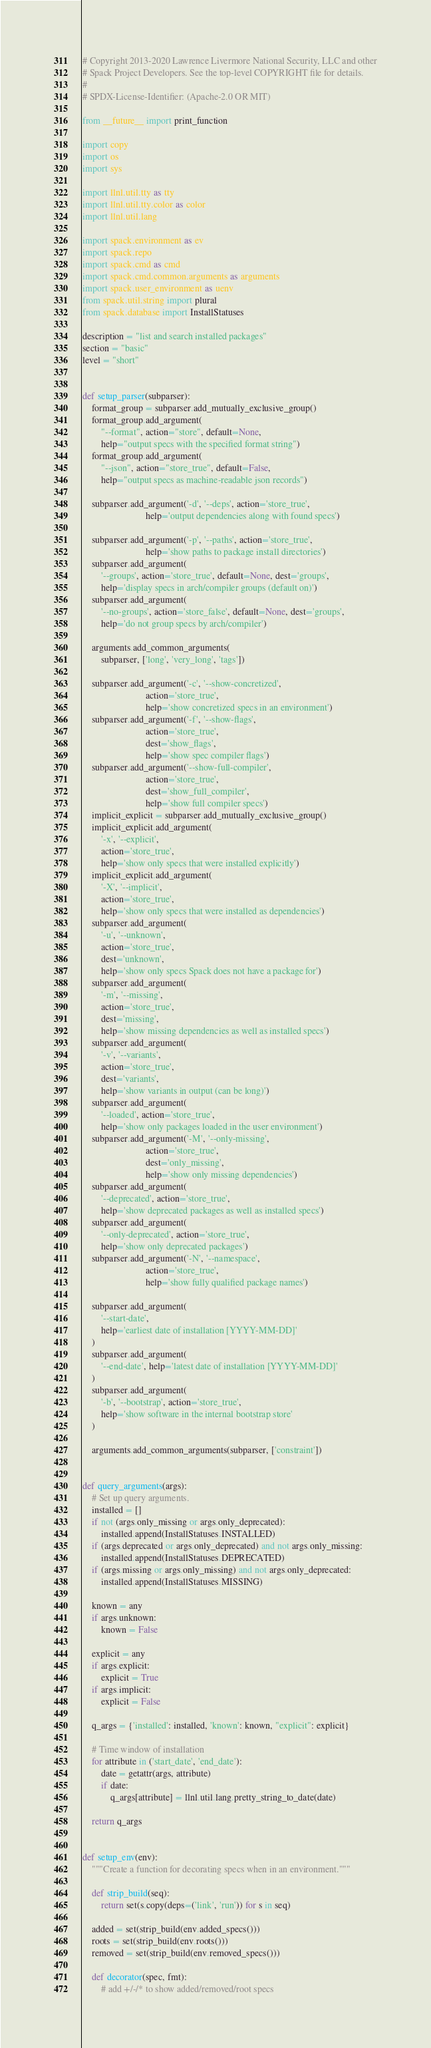<code> <loc_0><loc_0><loc_500><loc_500><_Python_># Copyright 2013-2020 Lawrence Livermore National Security, LLC and other
# Spack Project Developers. See the top-level COPYRIGHT file for details.
#
# SPDX-License-Identifier: (Apache-2.0 OR MIT)

from __future__ import print_function

import copy
import os
import sys

import llnl.util.tty as tty
import llnl.util.tty.color as color
import llnl.util.lang

import spack.environment as ev
import spack.repo
import spack.cmd as cmd
import spack.cmd.common.arguments as arguments
import spack.user_environment as uenv
from spack.util.string import plural
from spack.database import InstallStatuses

description = "list and search installed packages"
section = "basic"
level = "short"


def setup_parser(subparser):
    format_group = subparser.add_mutually_exclusive_group()
    format_group.add_argument(
        "--format", action="store", default=None,
        help="output specs with the specified format string")
    format_group.add_argument(
        "--json", action="store_true", default=False,
        help="output specs as machine-readable json records")

    subparser.add_argument('-d', '--deps', action='store_true',
                           help='output dependencies along with found specs')

    subparser.add_argument('-p', '--paths', action='store_true',
                           help='show paths to package install directories')
    subparser.add_argument(
        '--groups', action='store_true', default=None, dest='groups',
        help='display specs in arch/compiler groups (default on)')
    subparser.add_argument(
        '--no-groups', action='store_false', default=None, dest='groups',
        help='do not group specs by arch/compiler')

    arguments.add_common_arguments(
        subparser, ['long', 'very_long', 'tags'])

    subparser.add_argument('-c', '--show-concretized',
                           action='store_true',
                           help='show concretized specs in an environment')
    subparser.add_argument('-f', '--show-flags',
                           action='store_true',
                           dest='show_flags',
                           help='show spec compiler flags')
    subparser.add_argument('--show-full-compiler',
                           action='store_true',
                           dest='show_full_compiler',
                           help='show full compiler specs')
    implicit_explicit = subparser.add_mutually_exclusive_group()
    implicit_explicit.add_argument(
        '-x', '--explicit',
        action='store_true',
        help='show only specs that were installed explicitly')
    implicit_explicit.add_argument(
        '-X', '--implicit',
        action='store_true',
        help='show only specs that were installed as dependencies')
    subparser.add_argument(
        '-u', '--unknown',
        action='store_true',
        dest='unknown',
        help='show only specs Spack does not have a package for')
    subparser.add_argument(
        '-m', '--missing',
        action='store_true',
        dest='missing',
        help='show missing dependencies as well as installed specs')
    subparser.add_argument(
        '-v', '--variants',
        action='store_true',
        dest='variants',
        help='show variants in output (can be long)')
    subparser.add_argument(
        '--loaded', action='store_true',
        help='show only packages loaded in the user environment')
    subparser.add_argument('-M', '--only-missing',
                           action='store_true',
                           dest='only_missing',
                           help='show only missing dependencies')
    subparser.add_argument(
        '--deprecated', action='store_true',
        help='show deprecated packages as well as installed specs')
    subparser.add_argument(
        '--only-deprecated', action='store_true',
        help='show only deprecated packages')
    subparser.add_argument('-N', '--namespace',
                           action='store_true',
                           help='show fully qualified package names')

    subparser.add_argument(
        '--start-date',
        help='earliest date of installation [YYYY-MM-DD]'
    )
    subparser.add_argument(
        '--end-date', help='latest date of installation [YYYY-MM-DD]'
    )
    subparser.add_argument(
        '-b', '--bootstrap', action='store_true',
        help='show software in the internal bootstrap store'
    )

    arguments.add_common_arguments(subparser, ['constraint'])


def query_arguments(args):
    # Set up query arguments.
    installed = []
    if not (args.only_missing or args.only_deprecated):
        installed.append(InstallStatuses.INSTALLED)
    if (args.deprecated or args.only_deprecated) and not args.only_missing:
        installed.append(InstallStatuses.DEPRECATED)
    if (args.missing or args.only_missing) and not args.only_deprecated:
        installed.append(InstallStatuses.MISSING)

    known = any
    if args.unknown:
        known = False

    explicit = any
    if args.explicit:
        explicit = True
    if args.implicit:
        explicit = False

    q_args = {'installed': installed, 'known': known, "explicit": explicit}

    # Time window of installation
    for attribute in ('start_date', 'end_date'):
        date = getattr(args, attribute)
        if date:
            q_args[attribute] = llnl.util.lang.pretty_string_to_date(date)

    return q_args


def setup_env(env):
    """Create a function for decorating specs when in an environment."""

    def strip_build(seq):
        return set(s.copy(deps=('link', 'run')) for s in seq)

    added = set(strip_build(env.added_specs()))
    roots = set(strip_build(env.roots()))
    removed = set(strip_build(env.removed_specs()))

    def decorator(spec, fmt):
        # add +/-/* to show added/removed/root specs</code> 